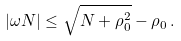Convert formula to latex. <formula><loc_0><loc_0><loc_500><loc_500>| \omega N | \leq \sqrt { N + \rho _ { 0 } ^ { 2 } } - \rho _ { 0 } \, .</formula> 